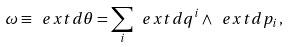Convert formula to latex. <formula><loc_0><loc_0><loc_500><loc_500>\omega \equiv \ e x t d \theta = \sum _ { i } \ e x t d q ^ { i } \wedge \ e x t d p _ { i } \, ,</formula> 